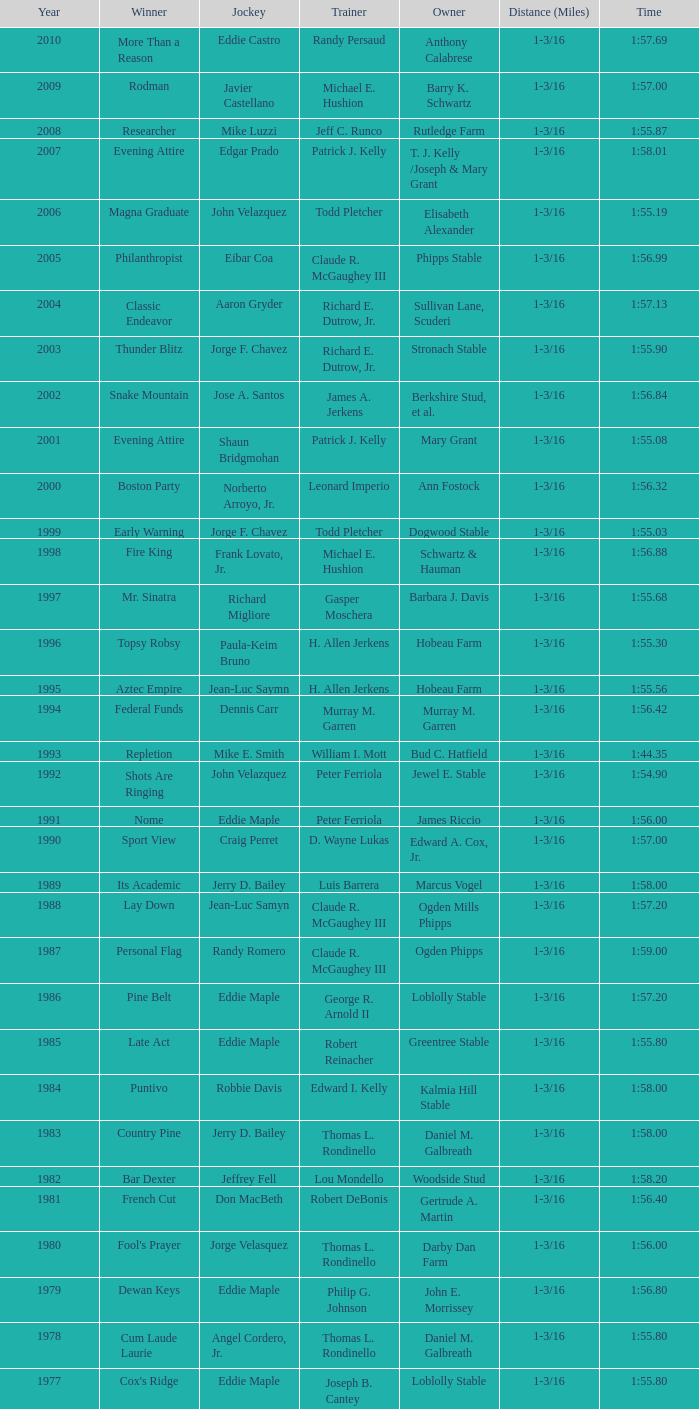What was salford ii's winning time? 1:44.20. Would you mind parsing the complete table? {'header': ['Year', 'Winner', 'Jockey', 'Trainer', 'Owner', 'Distance (Miles)', 'Time'], 'rows': [['2010', 'More Than a Reason', 'Eddie Castro', 'Randy Persaud', 'Anthony Calabrese', '1-3/16', '1:57.69'], ['2009', 'Rodman', 'Javier Castellano', 'Michael E. Hushion', 'Barry K. Schwartz', '1-3/16', '1:57.00'], ['2008', 'Researcher', 'Mike Luzzi', 'Jeff C. Runco', 'Rutledge Farm', '1-3/16', '1:55.87'], ['2007', 'Evening Attire', 'Edgar Prado', 'Patrick J. Kelly', 'T. J. Kelly /Joseph & Mary Grant', '1-3/16', '1:58.01'], ['2006', 'Magna Graduate', 'John Velazquez', 'Todd Pletcher', 'Elisabeth Alexander', '1-3/16', '1:55.19'], ['2005', 'Philanthropist', 'Eibar Coa', 'Claude R. McGaughey III', 'Phipps Stable', '1-3/16', '1:56.99'], ['2004', 'Classic Endeavor', 'Aaron Gryder', 'Richard E. Dutrow, Jr.', 'Sullivan Lane, Scuderi', '1-3/16', '1:57.13'], ['2003', 'Thunder Blitz', 'Jorge F. Chavez', 'Richard E. Dutrow, Jr.', 'Stronach Stable', '1-3/16', '1:55.90'], ['2002', 'Snake Mountain', 'Jose A. Santos', 'James A. Jerkens', 'Berkshire Stud, et al.', '1-3/16', '1:56.84'], ['2001', 'Evening Attire', 'Shaun Bridgmohan', 'Patrick J. Kelly', 'Mary Grant', '1-3/16', '1:55.08'], ['2000', 'Boston Party', 'Norberto Arroyo, Jr.', 'Leonard Imperio', 'Ann Fostock', '1-3/16', '1:56.32'], ['1999', 'Early Warning', 'Jorge F. Chavez', 'Todd Pletcher', 'Dogwood Stable', '1-3/16', '1:55.03'], ['1998', 'Fire King', 'Frank Lovato, Jr.', 'Michael E. Hushion', 'Schwartz & Hauman', '1-3/16', '1:56.88'], ['1997', 'Mr. Sinatra', 'Richard Migliore', 'Gasper Moschera', 'Barbara J. Davis', '1-3/16', '1:55.68'], ['1996', 'Topsy Robsy', 'Paula-Keim Bruno', 'H. Allen Jerkens', 'Hobeau Farm', '1-3/16', '1:55.30'], ['1995', 'Aztec Empire', 'Jean-Luc Saymn', 'H. Allen Jerkens', 'Hobeau Farm', '1-3/16', '1:55.56'], ['1994', 'Federal Funds', 'Dennis Carr', 'Murray M. Garren', 'Murray M. Garren', '1-3/16', '1:56.42'], ['1993', 'Repletion', 'Mike E. Smith', 'William I. Mott', 'Bud C. Hatfield', '1-3/16', '1:44.35'], ['1992', 'Shots Are Ringing', 'John Velazquez', 'Peter Ferriola', 'Jewel E. Stable', '1-3/16', '1:54.90'], ['1991', 'Nome', 'Eddie Maple', 'Peter Ferriola', 'James Riccio', '1-3/16', '1:56.00'], ['1990', 'Sport View', 'Craig Perret', 'D. Wayne Lukas', 'Edward A. Cox, Jr.', '1-3/16', '1:57.00'], ['1989', 'Its Academic', 'Jerry D. Bailey', 'Luis Barrera', 'Marcus Vogel', '1-3/16', '1:58.00'], ['1988', 'Lay Down', 'Jean-Luc Samyn', 'Claude R. McGaughey III', 'Ogden Mills Phipps', '1-3/16', '1:57.20'], ['1987', 'Personal Flag', 'Randy Romero', 'Claude R. McGaughey III', 'Ogden Phipps', '1-3/16', '1:59.00'], ['1986', 'Pine Belt', 'Eddie Maple', 'George R. Arnold II', 'Loblolly Stable', '1-3/16', '1:57.20'], ['1985', 'Late Act', 'Eddie Maple', 'Robert Reinacher', 'Greentree Stable', '1-3/16', '1:55.80'], ['1984', 'Puntivo', 'Robbie Davis', 'Edward I. Kelly', 'Kalmia Hill Stable', '1-3/16', '1:58.00'], ['1983', 'Country Pine', 'Jerry D. Bailey', 'Thomas L. Rondinello', 'Daniel M. Galbreath', '1-3/16', '1:58.00'], ['1982', 'Bar Dexter', 'Jeffrey Fell', 'Lou Mondello', 'Woodside Stud', '1-3/16', '1:58.20'], ['1981', 'French Cut', 'Don MacBeth', 'Robert DeBonis', 'Gertrude A. Martin', '1-3/16', '1:56.40'], ['1980', "Fool's Prayer", 'Jorge Velasquez', 'Thomas L. Rondinello', 'Darby Dan Farm', '1-3/16', '1:56.00'], ['1979', 'Dewan Keys', 'Eddie Maple', 'Philip G. Johnson', 'John E. Morrissey', '1-3/16', '1:56.80'], ['1978', 'Cum Laude Laurie', 'Angel Cordero, Jr.', 'Thomas L. Rondinello', 'Daniel M. Galbreath', '1-3/16', '1:55.80'], ['1977', "Cox's Ridge", 'Eddie Maple', 'Joseph B. Cantey', 'Loblolly Stable', '1-3/16', '1:55.80'], ['1976', "It's Freezing", 'Jacinto Vasquez', 'Anthony Basile', 'Bwamazon Farm', '1-3/16', '1:56.60'], ['1975', 'Hail The Pirates', 'Ron Turcotte', 'Thomas L. Rondinello', 'Daniel M. Galbreath', '1-3/16', '1:55.60'], ['1974', 'Free Hand', 'Jose Amy', 'Pancho Martin', 'Sigmund Sommer', '1-3/16', '1:55.00'], ['1973', 'True Knight', 'Angel Cordero, Jr.', 'Thomas L. Rondinello', 'Darby Dan Farm', '1-3/16', '1:55.00'], ['1972', 'Sunny And Mild', 'Michael Venezia', 'W. Preston King', 'Harry Rogosin', '1-3/16', '1:54.40'], ['1971', 'Red Reality', 'Jorge Velasquez', 'MacKenzie Miller', 'Cragwood Stables', '1-1/8', '1:49.60'], ['1970', 'Best Turn', 'Larry Adams', 'Reggie Cornell', 'Calumet Farm', '1-1/8', '1:50.00'], ['1969', 'Vif', 'Larry Adams', 'Clarence Meaux', 'Harvey Peltier', '1-1/8', '1:49.20'], ['1968', 'Irish Dude', 'Sandino Hernandez', 'Jack Bradley', 'Richard W. Taylor', '1-1/8', '1:49.60'], ['1967', 'Mr. Right', 'Heliodoro Gustines', 'Evan S. Jackson', 'Mrs. Peter Duchin', '1-1/8', '1:49.60'], ['1966', 'Amberoid', 'Walter Blum', 'Lucien Laurin', 'Reginald N. Webster', '1-1/8', '1:50.60'], ['1965', 'Prairie Schooner', 'Eddie Belmonte', 'James W. Smith', 'High Tide Stable', '1-1/8', '1:50.20'], ['1964', 'Third Martini', 'William Boland', 'H. Allen Jerkens', 'Hobeau Farm', '1-1/8', '1:50.60'], ['1963', 'Uppercut', 'Manuel Ycaza', 'Willard C. Freeman', 'William Harmonay', '1-1/8', '1:35.40'], ['1962', 'Grid Iron Hero', 'Manuel Ycaza', 'Laz Barrera', 'Emil Dolce', '1 mile', '1:34.00'], ['1961', 'Manassa Mauler', 'Braulio Baeza', 'Pancho Martin', 'Emil Dolce', '1 mile', '1:36.20'], ['1960', 'Cranberry Sauce', 'Heliodoro Gustines', 'not found', 'Elmendorf Farm', '1 mile', '1:36.20'], ['1959', 'Whitley', 'Eric Guerin', 'Max Hirsch', 'W. Arnold Hanger', '1 mile', '1:36.40'], ['1958', 'Oh Johnny', 'William Boland', 'Norman R. McLeod', 'Mrs. Wallace Gilroy', '1-1/16', '1:43.40'], ['1957', 'Bold Ruler', 'Eddie Arcaro', 'James E. Fitzsimmons', 'Wheatley Stable', '1-1/16', '1:42.80'], ['1956', 'Blessbull', 'Willie Lester', 'not found', 'Morris Sims', '1-1/16', '1:42.00'], ['1955', 'Fabulist', 'Ted Atkinson', 'William C. Winfrey', 'High Tide Stable', '1-1/16', '1:43.60'], ['1954', 'Find', 'Eric Guerin', 'William C. Winfrey', 'Alfred G. Vanderbilt II', '1-1/16', '1:44.00'], ['1953', 'Flaunt', 'S. Cole', 'Hubert W. Williams', 'Arnold Skjeveland', '1-1/16', '1:44.20'], ['1952', 'County Delight', 'Dave Gorman', 'James E. Ryan', 'Rokeby Stable', '1-1/16', '1:43.60'], ['1951', 'Sheilas Reward', 'Ovie Scurlock', 'Eugene Jacobs', 'Mrs. Louis Lazare', '1-1/16', '1:44.60'], ['1950', 'Three Rings', 'Hedley Woodhouse', 'Willie Knapp', 'Mrs. Evelyn L. Hopkins', '1-1/16', '1:44.60'], ['1949', 'Three Rings', 'Ted Atkinson', 'Willie Knapp', 'Mrs. Evelyn L. Hopkins', '1-1/16', '1:47.40'], ['1948', 'Knockdown', 'Ferrill Zufelt', 'Tom Smith', 'Maine Chance Farm', '1-1/16', '1:44.60'], ['1947', 'Gallorette', 'Job Dean Jessop', 'Edward A. Christmas', 'William L. Brann', '1-1/16', '1:45.40'], ['1946', 'Helioptic', 'Paul Miller', 'not found', 'William Goadby Loew', '1-1/16', '1:43.20'], ['1945', 'Olympic Zenith', 'Conn McCreary', 'Willie Booth', 'William G. Helis', '1-1/16', '1:45.60'], ['1944', 'First Fiddle', 'Johnny Longden', 'Edward Mulrenan', 'Mrs. Edward Mulrenan', '1-1/16', '1:44.20'], ['1943', 'The Rhymer', 'Conn McCreary', 'John M. Gaver, Sr.', 'Greentree Stable', '1-1/16', '1:45.00'], ['1942', 'Waller', 'Billie Thompson', 'A. G. Robertson', 'John C. Clark', '1-1/16', '1:44.00'], ['1941', 'Salford II', 'Don Meade', 'not found', 'Ralph B. Strassburger', '1-1/16', '1:44.20'], ['1940', 'He Did', 'Eddie Arcaro', 'J. Thomas Taylor', 'W. Arnold Hanger', '1-1/16', '1:43.20'], ['1939', 'Lovely Night', 'Johnny Longden', 'Henry McDaniel', 'Mrs. F. Ambrose Clark', '1 mile', '1:36.40'], ['1938', 'War Admiral', 'Charles Kurtsinger', 'George Conway', 'Glen Riddle Farm', '1 mile', '1:36.80'], ['1937', 'Snark', 'Johnny Longden', 'James E. Fitzsimmons', 'Wheatley Stable', '1 mile', '1:37.40'], ['1936', 'Good Gamble', 'Samuel Renick', 'Bud Stotler', 'Alfred G. Vanderbilt II', '1 mile', '1:37.20'], ['1935', 'King Saxon', 'Calvin Rainey', 'Charles Shaw', 'C. H. Knebelkamp', '1 mile', '1:37.20'], ['1934', 'Singing Wood', 'Robert Jones', 'James W. Healy', 'Liz Whitney', '1 mile', '1:38.60'], ['1933', 'Kerry Patch', 'Robert Wholey', 'Joseph A. Notter', 'Lee Rosenberg', '1 mile', '1:38.00'], ['1932', 'Halcyon', 'Hank Mills', 'T. J. Healey', 'C. V. Whitney', '1 mile', '1:38.00'], ['1931', 'Halcyon', 'G. Rose', 'T. J. Healey', 'C. V. Whitney', '1 mile', '1:38.40'], ['1930', 'Kildare', 'John Passero', 'Norman Tallman', 'Newtondale Stable', '1 mile', '1:38.60'], ['1929', 'Comstockery', 'Sidney Hebert', 'Thomas W. Murphy', 'Greentree Stable', '1 mile', '1:39.60'], ['1928', 'Kentucky II', 'George Schreiner', 'Max Hirsch', 'A. Charles Schwartz', '1 mile', '1:38.80'], ['1927', 'Light Carbine', 'James McCoy', 'M. J. Dunlevy', 'I. B. Humphreys', '1 mile', '1:36.80'], ['1926', 'Macaw', 'Linus McAtee', 'James G. Rowe, Sr.', 'Harry Payne Whitney', '1 mile', '1:37.00'], ['1925', 'Mad Play', 'Laverne Fator', 'Sam Hildreth', 'Rancocas Stable', '1 mile', '1:36.60'], ['1924', 'Mad Hatter', 'Earl Sande', 'Sam Hildreth', 'Rancocas Stable', '1 mile', '1:36.60'], ['1923', 'Zev', 'Earl Sande', 'Sam Hildreth', 'Rancocas Stable', '1 mile', '1:37.00'], ['1922', 'Grey Lag', 'Laverne Fator', 'Sam Hildreth', 'Rancocas Stable', '1 mile', '1:38.00'], ['1921', 'John P. Grier', 'Frank Keogh', 'James G. Rowe, Sr.', 'Harry Payne Whitney', '1 mile', '1:36.00'], ['1920', 'Cirrus', 'Lavelle Ensor', 'Sam Hildreth', 'Sam Hildreth', '1 mile', '1:38.00'], ['1919', 'Star Master', 'Merritt Buxton', 'Walter B. Jennings', 'A. Kingsley Macomber', '1 mile', '1:37.60'], ['1918', 'Roamer', 'Lawrence Lyke', 'A. J. Goldsborough', 'Andrew Miller', '1 mile', '1:36.60'], ['1917', 'Old Rosebud', 'Frank Robinson', 'Frank D. Weir', 'F. D. Weir & Hamilton C. Applegate', '1 mile', '1:37.60'], ['1916', 'Short Grass', 'Frank Keogh', 'not found', 'Emil Herz', '1 mile', '1:36.40'], ['1915', 'Roamer', 'James Butwell', 'A. J. Goldsborough', 'Andrew Miller', '1 mile', '1:39.20'], ['1914', 'Flying Fairy', 'Tommy Davies', 'J. Simon Healy', 'Edward B. Cassatt', '1 mile', '1:42.20'], ['1913', 'No Race', 'No Race', 'No Race', 'No Race', '1 mile', 'no race'], ['1912', 'No Race', 'No Race', 'No Race', 'No Race', '1 mile', 'no race'], ['1911', 'No Race', 'No Race', 'No Race', 'No Race', '1 mile', 'no race'], ['1910', 'Arasee', 'Buddy Glass', 'Andrew G. Blakely', 'Samuel Emery', '1 mile', '1:39.80'], ['1909', 'No Race', 'No Race', 'No Race', 'No Race', '1 mile', 'no race'], ['1908', 'Jack Atkin', 'Phil Musgrave', 'Herman R. Brandt', 'Barney Schreiber', '1 mile', '1:39.00'], ['1907', 'W. H. Carey', 'George Mountain', 'James Blute', 'Richard F. Carman', '1 mile', '1:40.00'], ['1906', "Ram's Horn", 'L. Perrine', 'W. S. "Jim" Williams', 'W. S. "Jim" Williams', '1 mile', '1:39.40'], ['1905', 'St. Valentine', 'William Crimmins', 'John Shields', 'Alexander Shields', '1 mile', '1:39.20'], ['1904', 'Rosetint', 'Thomas H. Burns', 'James Boden', 'John Boden', '1 mile', '1:39.20'], ['1903', 'Yellow Tail', 'Willie Shaw', 'H. E. Rowell', 'John Hackett', '1m 70yds', '1:45.20'], ['1902', 'Margravite', 'Otto Wonderly', 'not found', 'Charles Fleischmann Sons', '1m 70 yds', '1:46.00']]} 